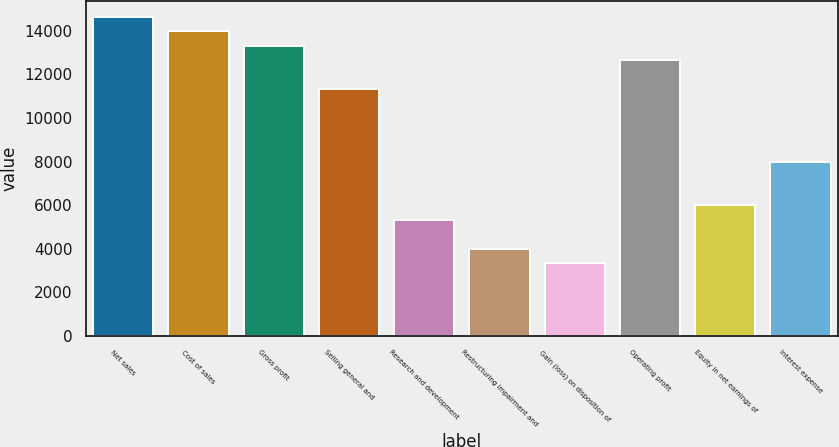Convert chart. <chart><loc_0><loc_0><loc_500><loc_500><bar_chart><fcel>Net sales<fcel>Cost of sales<fcel>Gross profit<fcel>Selling general and<fcel>Research and development<fcel>Restructuring impairment and<fcel>Gain (loss) on disposition of<fcel>Operating profit<fcel>Equity in net earnings of<fcel>Interest expense<nl><fcel>14643.2<fcel>13977.6<fcel>13312<fcel>11315.2<fcel>5324.81<fcel>3993.61<fcel>3328.01<fcel>12646.4<fcel>5990.41<fcel>7987.21<nl></chart> 